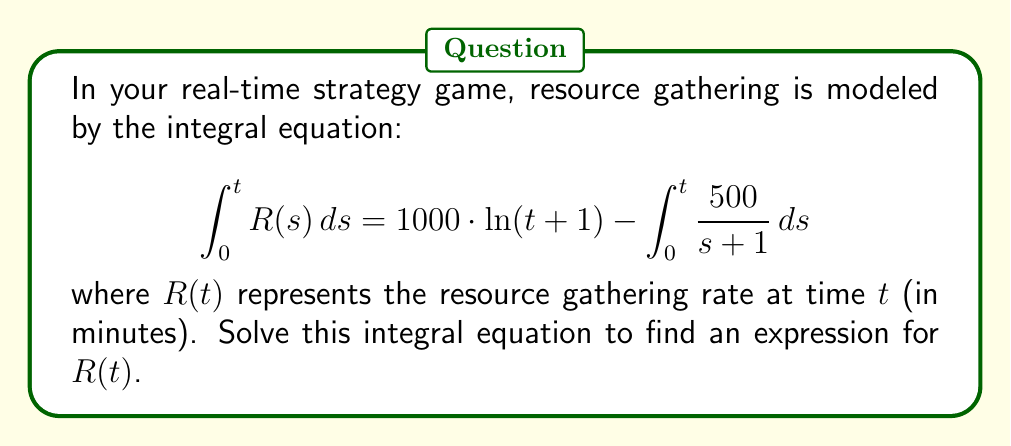Can you solve this math problem? Let's solve this step-by-step:

1) First, we need to differentiate both sides of the equation with respect to $t$. Using the Fundamental Theorem of Calculus, we get:

   $$R(t) = \frac{d}{dt}\left[1000 \cdot \ln(t+1)\right] - \frac{d}{dt}\left[\int_0^t \frac{500}{s+1} ds\right]$$

2) For the left term:
   $$\frac{d}{dt}\left[1000 \cdot \ln(t+1)\right] = 1000 \cdot \frac{1}{t+1}$$

3) For the right term, we can use the Fundamental Theorem of Calculus again:
   $$\frac{d}{dt}\left[\int_0^t \frac{500}{s+1} ds\right] = \frac{500}{t+1}$$

4) Substituting these back into our equation:

   $$R(t) = 1000 \cdot \frac{1}{t+1} - \frac{500}{t+1}$$

5) Simplifying:

   $$R(t) = \frac{1000 - 500}{t+1} = \frac{500}{t+1}$$

Therefore, the resource gathering rate $R(t)$ at time $t$ is given by $\frac{500}{t+1}$.
Answer: $R(t) = \frac{500}{t+1}$ 